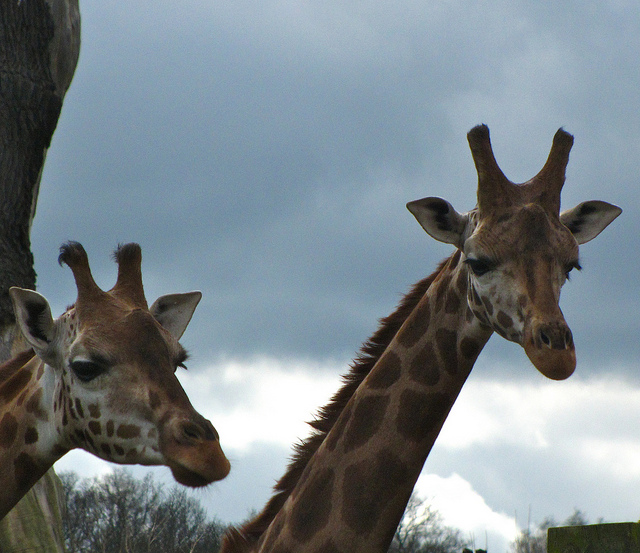<image>What are the things on the top of the giraffe's head? I am not sure what is on top of the giraffe's head. It can be horns or ossicones. What are the things on the top of the giraffe's head? I don't know what are the things on the top of the giraffe's head. They can be horns or ossicones. 